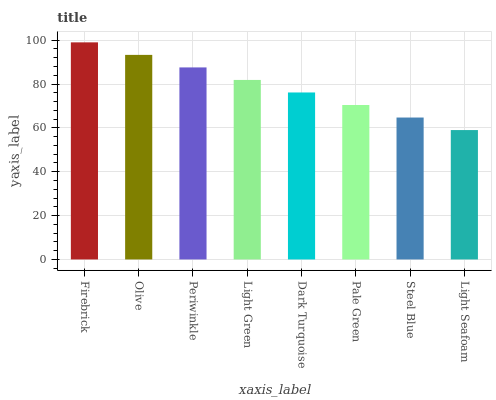Is Light Seafoam the minimum?
Answer yes or no. Yes. Is Firebrick the maximum?
Answer yes or no. Yes. Is Olive the minimum?
Answer yes or no. No. Is Olive the maximum?
Answer yes or no. No. Is Firebrick greater than Olive?
Answer yes or no. Yes. Is Olive less than Firebrick?
Answer yes or no. Yes. Is Olive greater than Firebrick?
Answer yes or no. No. Is Firebrick less than Olive?
Answer yes or no. No. Is Light Green the high median?
Answer yes or no. Yes. Is Dark Turquoise the low median?
Answer yes or no. Yes. Is Light Seafoam the high median?
Answer yes or no. No. Is Firebrick the low median?
Answer yes or no. No. 